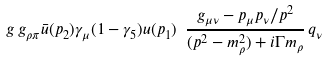Convert formula to latex. <formula><loc_0><loc_0><loc_500><loc_500>g \, g _ { \rho \pi } \bar { u } ( p _ { 2 } ) \gamma _ { \mu } ( 1 - \gamma _ { 5 } ) u ( p _ { 1 } ) \ \frac { g _ { \mu \nu } - p _ { \mu } p _ { \nu } / p ^ { 2 } } { ( p ^ { 2 } - m ^ { 2 } _ { \rho } ) + i \Gamma m _ { \rho } } \, q _ { \nu }</formula> 